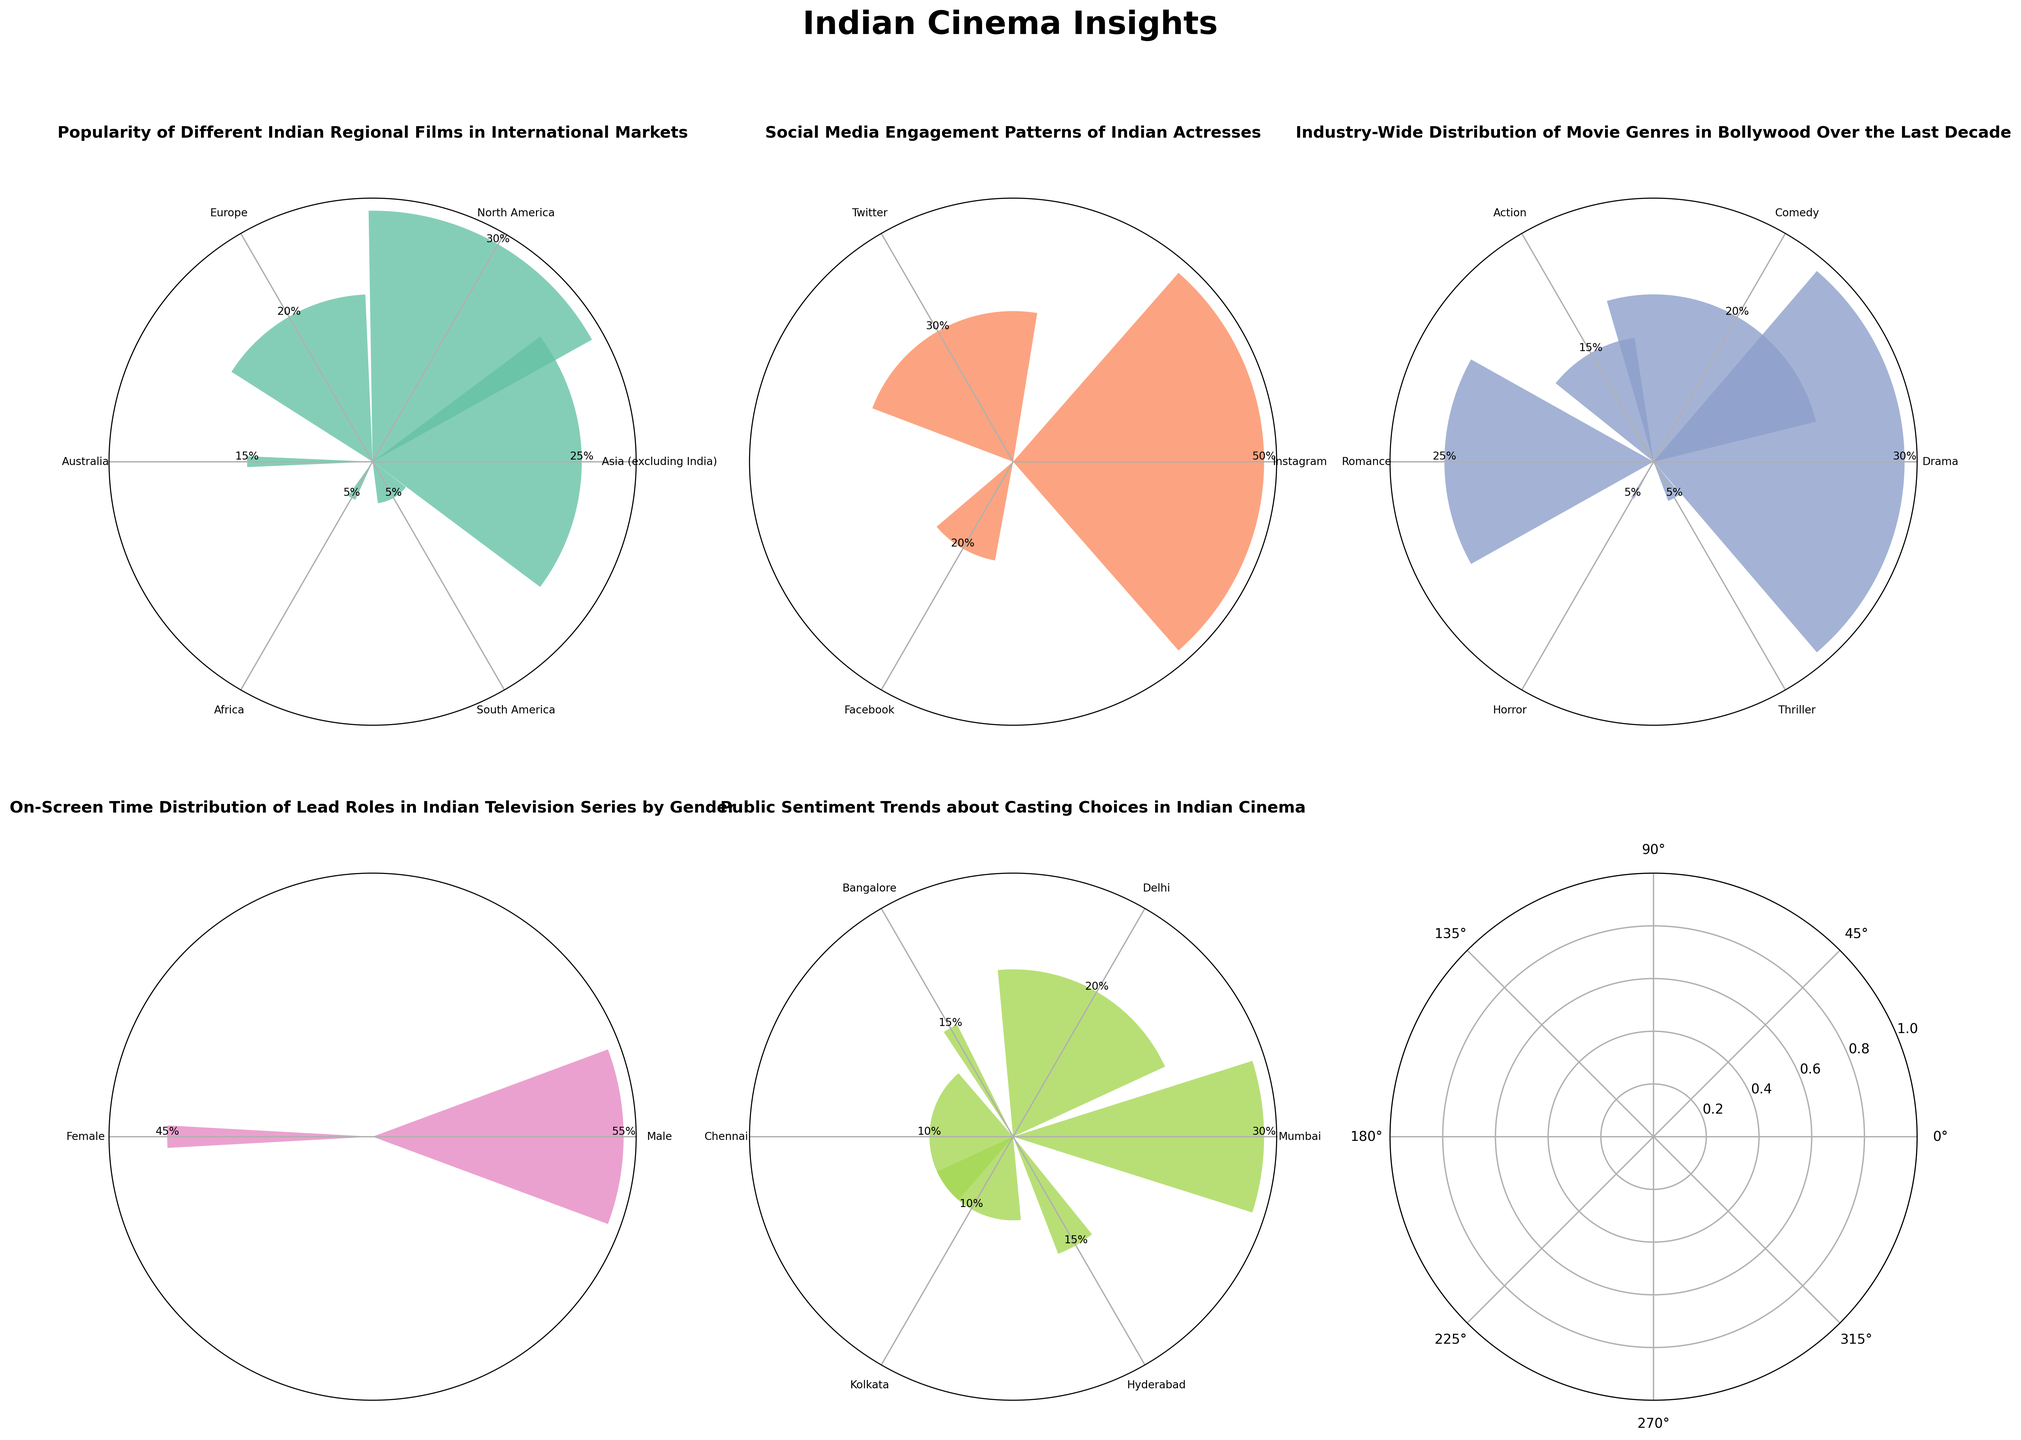What is the title of the entire figure? The title of the entire figure is stated at the top and it reads "Indian Cinema Insights".
Answer: Indian Cinema Insights Which continent has the highest popularity for Indian regional films in international markets? By looking at the subplot related to the "Popularity of Different Indian Regional Films in International Markets", the bar representing "North America" extends the farthest, indicating the highest percentage.
Answer: North America On which social media platform do Indian actresses have the highest engagement? In the subplot for "Social Media Engagement Patterns of Indian Actresses, Broken Down by Platform", the bar for "Instagram" extends the farthest, indicating the highest percentage.
Answer: Instagram What percentage of Bollywood movies were Dramas over the last decade? The subplot titled "Industry-Wide Distribution of Movie Genres in Bollywood Over the Last Decade" shows the largest bar under the category "Drama" with a label indicating its percentage.
Answer: 30% Which gender has more on-screen time in Indian television series? The subplot "On-Screen Time Distribution of Lead Roles in Indian Television Series by Gender" shows that the bar for "Male" extends further than the one for "Female", indicating a higher percentage.
Answer: Male How does the popularity of Indian regional films in Europe compare to Australia? Looking at the subplot "Popularity of Different Indian Regional Films in International Markets", the bar for "Europe" is slightly larger than the bar for "Australia".
Answer: Europe is more popular than Australia What is the combined percentage for Comedy and Romance genres in Bollywood? The subplot for "Industry-Wide Distribution of Movie Genres in Bollywood Over the Last Decade" shows Comedy at 20% and Romance at 25%. The sum of these two percentages is 20% + 25%.
Answer: 45% In which Indian city is public sentiment about casting choices the lowest? In the subplot "Public Sentiment Trends about Casting Choices in Indian Cinema, Categorized by Major Indian Cities", both "Chennai" and "Kolkata" have the shortest bars, each labeled with the same percentage.
Answer: Chennai and Kolkata What percentage of social media engagement for Indian actresses is seen on Facebook? The subplot for "Social Media Engagement Patterns of Indian Actresses, Broken Down by Platform" shows a bar labeled "Facebook" with a specific percentage.
Answer: 20% Which Indian city shows the highest public sentiment about casting choices in Indian cinema? In the subplot "Public Sentiment Trends about Casting Choices in Indian Cinema", the bar for "Mumbai" extends the farthest, indicating the highest percentage.
Answer: Mumbai 